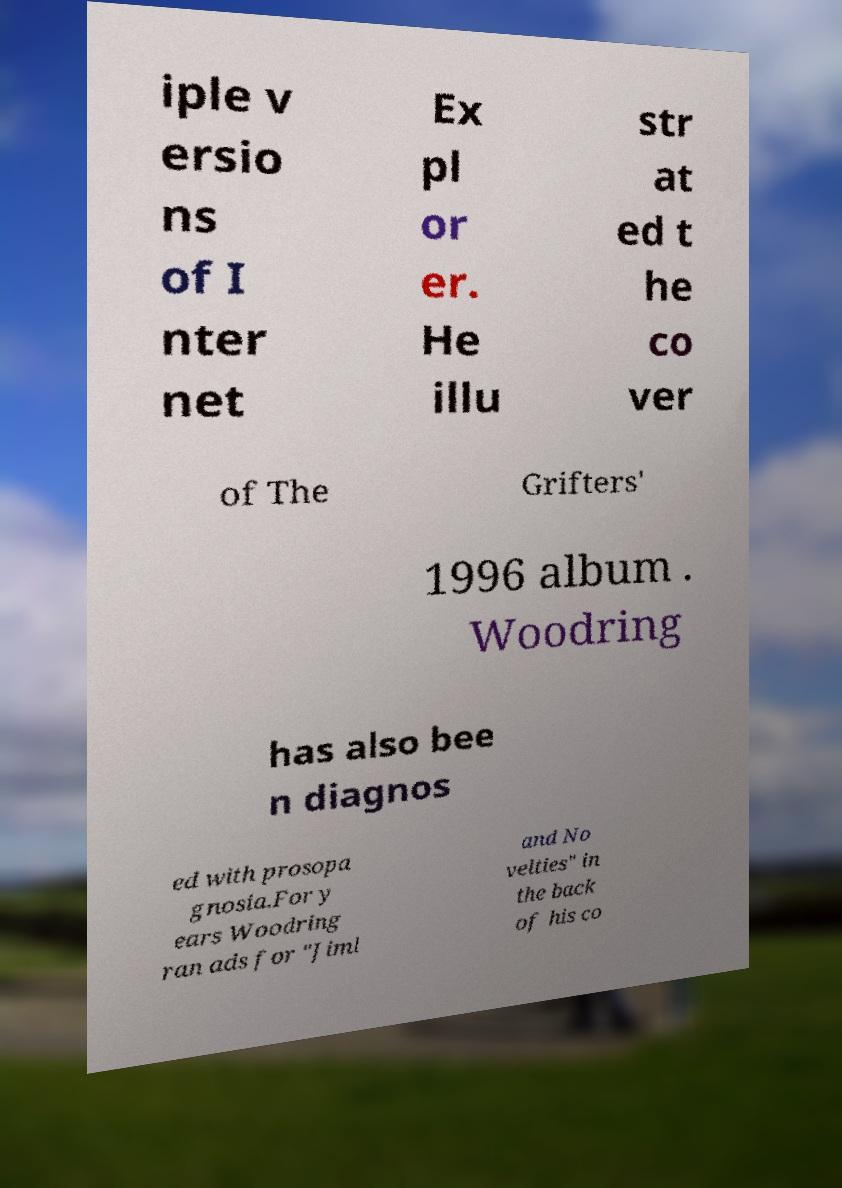Can you accurately transcribe the text from the provided image for me? iple v ersio ns of I nter net Ex pl or er. He illu str at ed t he co ver of The Grifters' 1996 album . Woodring has also bee n diagnos ed with prosopa gnosia.For y ears Woodring ran ads for "Jiml and No velties" in the back of his co 